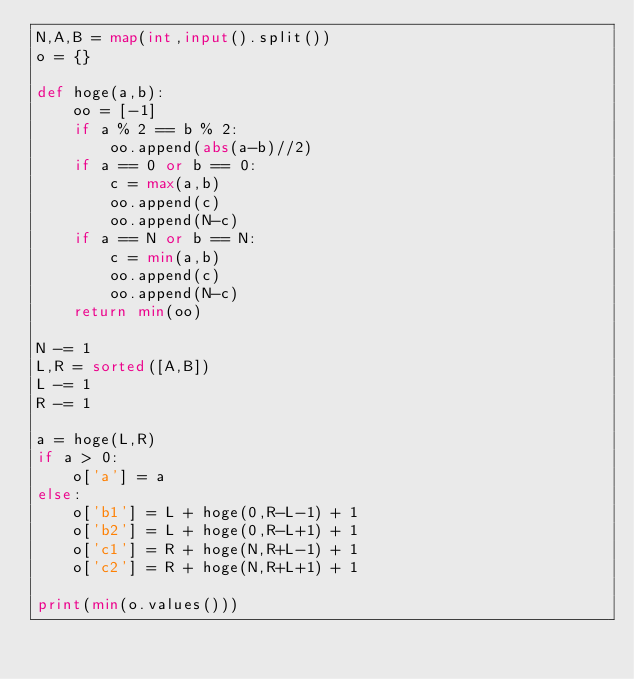Convert code to text. <code><loc_0><loc_0><loc_500><loc_500><_Python_>N,A,B = map(int,input().split())
o = {}

def hoge(a,b):
    oo = [-1]
    if a % 2 == b % 2:
        oo.append(abs(a-b)//2)
    if a == 0 or b == 0:
        c = max(a,b)
        oo.append(c)
        oo.append(N-c)
    if a == N or b == N:
        c = min(a,b)
        oo.append(c)
        oo.append(N-c)
    return min(oo)

N -= 1
L,R = sorted([A,B])
L -= 1
R -= 1

a = hoge(L,R)
if a > 0:
    o['a'] = a
else:
    o['b1'] = L + hoge(0,R-L-1) + 1
    o['b2'] = L + hoge(0,R-L+1) + 1
    o['c1'] = R + hoge(N,R+L-1) + 1
    o['c2'] = R + hoge(N,R+L+1) + 1

print(min(o.values()))</code> 